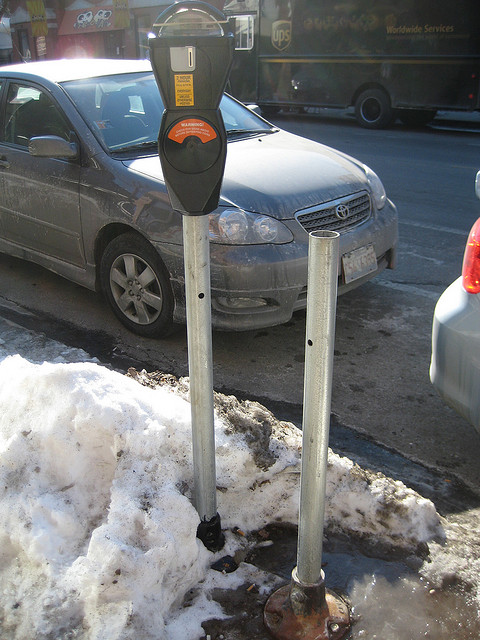Identify the text contained in this image. UpS 